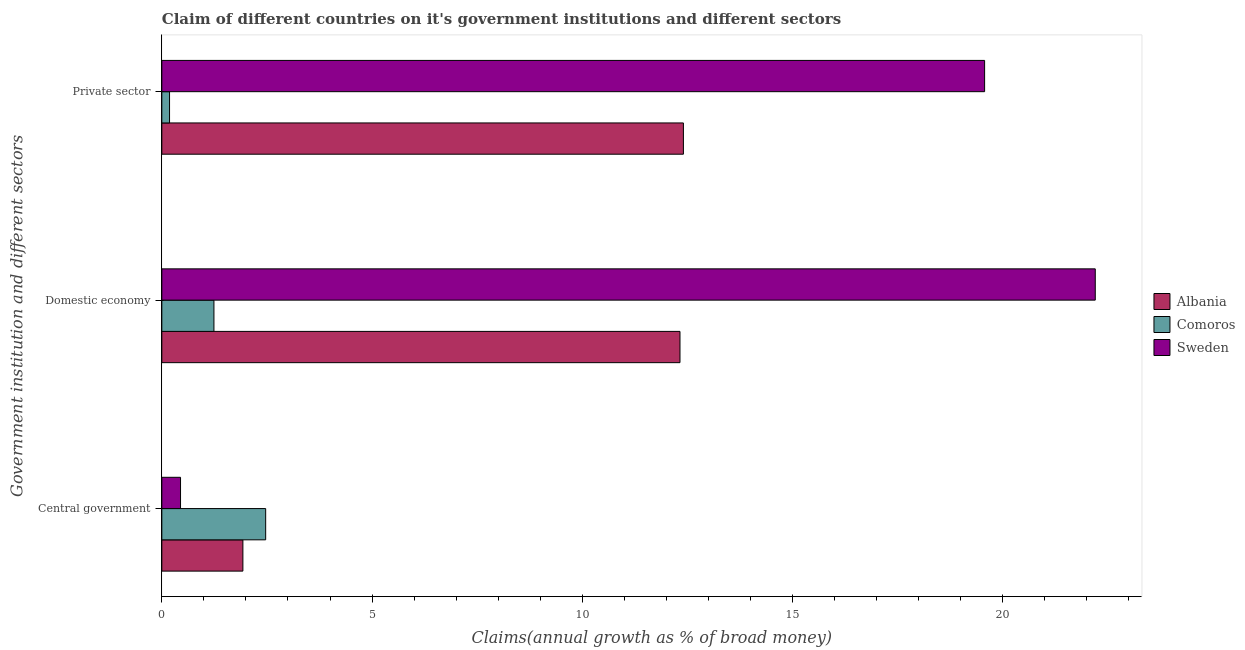How many different coloured bars are there?
Offer a very short reply. 3. Are the number of bars on each tick of the Y-axis equal?
Provide a succinct answer. Yes. What is the label of the 1st group of bars from the top?
Ensure brevity in your answer.  Private sector. What is the percentage of claim on the private sector in Albania?
Offer a terse response. 12.41. Across all countries, what is the maximum percentage of claim on the domestic economy?
Your answer should be compact. 22.2. Across all countries, what is the minimum percentage of claim on the domestic economy?
Keep it short and to the point. 1.24. In which country was the percentage of claim on the domestic economy maximum?
Your response must be concise. Sweden. What is the total percentage of claim on the domestic economy in the graph?
Your answer should be compact. 35.76. What is the difference between the percentage of claim on the central government in Comoros and that in Sweden?
Provide a short and direct response. 2.02. What is the difference between the percentage of claim on the central government in Sweden and the percentage of claim on the domestic economy in Comoros?
Your answer should be compact. -0.79. What is the average percentage of claim on the private sector per country?
Give a very brief answer. 10.72. What is the difference between the percentage of claim on the domestic economy and percentage of claim on the private sector in Sweden?
Give a very brief answer. 2.63. In how many countries, is the percentage of claim on the domestic economy greater than 4 %?
Keep it short and to the point. 2. What is the ratio of the percentage of claim on the private sector in Comoros to that in Sweden?
Give a very brief answer. 0.01. What is the difference between the highest and the second highest percentage of claim on the private sector?
Your response must be concise. 7.16. What is the difference between the highest and the lowest percentage of claim on the domestic economy?
Your response must be concise. 20.96. In how many countries, is the percentage of claim on the private sector greater than the average percentage of claim on the private sector taken over all countries?
Offer a very short reply. 2. Is the sum of the percentage of claim on the private sector in Comoros and Sweden greater than the maximum percentage of claim on the domestic economy across all countries?
Give a very brief answer. No. What does the 1st bar from the top in Private sector represents?
Your answer should be very brief. Sweden. What does the 1st bar from the bottom in Private sector represents?
Offer a very short reply. Albania. How many countries are there in the graph?
Offer a very short reply. 3. What is the difference between two consecutive major ticks on the X-axis?
Offer a terse response. 5. Are the values on the major ticks of X-axis written in scientific E-notation?
Keep it short and to the point. No. Does the graph contain any zero values?
Your answer should be compact. No. Does the graph contain grids?
Give a very brief answer. No. How many legend labels are there?
Provide a succinct answer. 3. What is the title of the graph?
Give a very brief answer. Claim of different countries on it's government institutions and different sectors. What is the label or title of the X-axis?
Provide a short and direct response. Claims(annual growth as % of broad money). What is the label or title of the Y-axis?
Give a very brief answer. Government institution and different sectors. What is the Claims(annual growth as % of broad money) of Albania in Central government?
Make the answer very short. 1.93. What is the Claims(annual growth as % of broad money) of Comoros in Central government?
Ensure brevity in your answer.  2.47. What is the Claims(annual growth as % of broad money) of Sweden in Central government?
Your answer should be compact. 0.44. What is the Claims(annual growth as % of broad money) of Albania in Domestic economy?
Offer a very short reply. 12.32. What is the Claims(annual growth as % of broad money) of Comoros in Domestic economy?
Make the answer very short. 1.24. What is the Claims(annual growth as % of broad money) in Sweden in Domestic economy?
Your answer should be compact. 22.2. What is the Claims(annual growth as % of broad money) in Albania in Private sector?
Provide a short and direct response. 12.41. What is the Claims(annual growth as % of broad money) in Comoros in Private sector?
Give a very brief answer. 0.18. What is the Claims(annual growth as % of broad money) in Sweden in Private sector?
Your response must be concise. 19.57. Across all Government institution and different sectors, what is the maximum Claims(annual growth as % of broad money) of Albania?
Your answer should be very brief. 12.41. Across all Government institution and different sectors, what is the maximum Claims(annual growth as % of broad money) of Comoros?
Keep it short and to the point. 2.47. Across all Government institution and different sectors, what is the maximum Claims(annual growth as % of broad money) in Sweden?
Keep it short and to the point. 22.2. Across all Government institution and different sectors, what is the minimum Claims(annual growth as % of broad money) of Albania?
Provide a succinct answer. 1.93. Across all Government institution and different sectors, what is the minimum Claims(annual growth as % of broad money) of Comoros?
Your answer should be very brief. 0.18. Across all Government institution and different sectors, what is the minimum Claims(annual growth as % of broad money) in Sweden?
Your response must be concise. 0.44. What is the total Claims(annual growth as % of broad money) in Albania in the graph?
Ensure brevity in your answer.  26.66. What is the total Claims(annual growth as % of broad money) in Comoros in the graph?
Provide a succinct answer. 3.89. What is the total Claims(annual growth as % of broad money) in Sweden in the graph?
Keep it short and to the point. 42.22. What is the difference between the Claims(annual growth as % of broad money) in Albania in Central government and that in Domestic economy?
Your answer should be very brief. -10.4. What is the difference between the Claims(annual growth as % of broad money) of Comoros in Central government and that in Domestic economy?
Give a very brief answer. 1.23. What is the difference between the Claims(annual growth as % of broad money) of Sweden in Central government and that in Domestic economy?
Give a very brief answer. -21.76. What is the difference between the Claims(annual growth as % of broad money) of Albania in Central government and that in Private sector?
Your response must be concise. -10.48. What is the difference between the Claims(annual growth as % of broad money) of Comoros in Central government and that in Private sector?
Your response must be concise. 2.29. What is the difference between the Claims(annual growth as % of broad money) of Sweden in Central government and that in Private sector?
Ensure brevity in your answer.  -19.12. What is the difference between the Claims(annual growth as % of broad money) of Albania in Domestic economy and that in Private sector?
Offer a very short reply. -0.08. What is the difference between the Claims(annual growth as % of broad money) of Comoros in Domestic economy and that in Private sector?
Provide a short and direct response. 1.06. What is the difference between the Claims(annual growth as % of broad money) of Sweden in Domestic economy and that in Private sector?
Keep it short and to the point. 2.63. What is the difference between the Claims(annual growth as % of broad money) of Albania in Central government and the Claims(annual growth as % of broad money) of Comoros in Domestic economy?
Your response must be concise. 0.69. What is the difference between the Claims(annual growth as % of broad money) in Albania in Central government and the Claims(annual growth as % of broad money) in Sweden in Domestic economy?
Keep it short and to the point. -20.27. What is the difference between the Claims(annual growth as % of broad money) of Comoros in Central government and the Claims(annual growth as % of broad money) of Sweden in Domestic economy?
Give a very brief answer. -19.73. What is the difference between the Claims(annual growth as % of broad money) of Albania in Central government and the Claims(annual growth as % of broad money) of Comoros in Private sector?
Provide a short and direct response. 1.74. What is the difference between the Claims(annual growth as % of broad money) in Albania in Central government and the Claims(annual growth as % of broad money) in Sweden in Private sector?
Provide a succinct answer. -17.64. What is the difference between the Claims(annual growth as % of broad money) of Comoros in Central government and the Claims(annual growth as % of broad money) of Sweden in Private sector?
Keep it short and to the point. -17.1. What is the difference between the Claims(annual growth as % of broad money) of Albania in Domestic economy and the Claims(annual growth as % of broad money) of Comoros in Private sector?
Provide a succinct answer. 12.14. What is the difference between the Claims(annual growth as % of broad money) of Albania in Domestic economy and the Claims(annual growth as % of broad money) of Sweden in Private sector?
Give a very brief answer. -7.25. What is the difference between the Claims(annual growth as % of broad money) of Comoros in Domestic economy and the Claims(annual growth as % of broad money) of Sweden in Private sector?
Your response must be concise. -18.33. What is the average Claims(annual growth as % of broad money) in Albania per Government institution and different sectors?
Provide a succinct answer. 8.89. What is the average Claims(annual growth as % of broad money) of Comoros per Government institution and different sectors?
Provide a succinct answer. 1.3. What is the average Claims(annual growth as % of broad money) in Sweden per Government institution and different sectors?
Your answer should be very brief. 14.07. What is the difference between the Claims(annual growth as % of broad money) of Albania and Claims(annual growth as % of broad money) of Comoros in Central government?
Give a very brief answer. -0.54. What is the difference between the Claims(annual growth as % of broad money) of Albania and Claims(annual growth as % of broad money) of Sweden in Central government?
Your response must be concise. 1.48. What is the difference between the Claims(annual growth as % of broad money) of Comoros and Claims(annual growth as % of broad money) of Sweden in Central government?
Offer a very short reply. 2.02. What is the difference between the Claims(annual growth as % of broad money) of Albania and Claims(annual growth as % of broad money) of Comoros in Domestic economy?
Offer a terse response. 11.08. What is the difference between the Claims(annual growth as % of broad money) in Albania and Claims(annual growth as % of broad money) in Sweden in Domestic economy?
Offer a very short reply. -9.88. What is the difference between the Claims(annual growth as % of broad money) of Comoros and Claims(annual growth as % of broad money) of Sweden in Domestic economy?
Your answer should be very brief. -20.96. What is the difference between the Claims(annual growth as % of broad money) in Albania and Claims(annual growth as % of broad money) in Comoros in Private sector?
Provide a succinct answer. 12.22. What is the difference between the Claims(annual growth as % of broad money) in Albania and Claims(annual growth as % of broad money) in Sweden in Private sector?
Keep it short and to the point. -7.16. What is the difference between the Claims(annual growth as % of broad money) in Comoros and Claims(annual growth as % of broad money) in Sweden in Private sector?
Your response must be concise. -19.39. What is the ratio of the Claims(annual growth as % of broad money) in Albania in Central government to that in Domestic economy?
Keep it short and to the point. 0.16. What is the ratio of the Claims(annual growth as % of broad money) in Comoros in Central government to that in Domestic economy?
Provide a short and direct response. 1.99. What is the ratio of the Claims(annual growth as % of broad money) of Sweden in Central government to that in Domestic economy?
Your answer should be very brief. 0.02. What is the ratio of the Claims(annual growth as % of broad money) of Albania in Central government to that in Private sector?
Keep it short and to the point. 0.16. What is the ratio of the Claims(annual growth as % of broad money) of Comoros in Central government to that in Private sector?
Make the answer very short. 13.46. What is the ratio of the Claims(annual growth as % of broad money) of Sweden in Central government to that in Private sector?
Your answer should be compact. 0.02. What is the ratio of the Claims(annual growth as % of broad money) in Albania in Domestic economy to that in Private sector?
Keep it short and to the point. 0.99. What is the ratio of the Claims(annual growth as % of broad money) of Comoros in Domestic economy to that in Private sector?
Your response must be concise. 6.76. What is the ratio of the Claims(annual growth as % of broad money) in Sweden in Domestic economy to that in Private sector?
Your answer should be very brief. 1.13. What is the difference between the highest and the second highest Claims(annual growth as % of broad money) in Albania?
Your response must be concise. 0.08. What is the difference between the highest and the second highest Claims(annual growth as % of broad money) of Comoros?
Keep it short and to the point. 1.23. What is the difference between the highest and the second highest Claims(annual growth as % of broad money) of Sweden?
Offer a very short reply. 2.63. What is the difference between the highest and the lowest Claims(annual growth as % of broad money) of Albania?
Offer a terse response. 10.48. What is the difference between the highest and the lowest Claims(annual growth as % of broad money) of Comoros?
Provide a succinct answer. 2.29. What is the difference between the highest and the lowest Claims(annual growth as % of broad money) in Sweden?
Your answer should be compact. 21.76. 